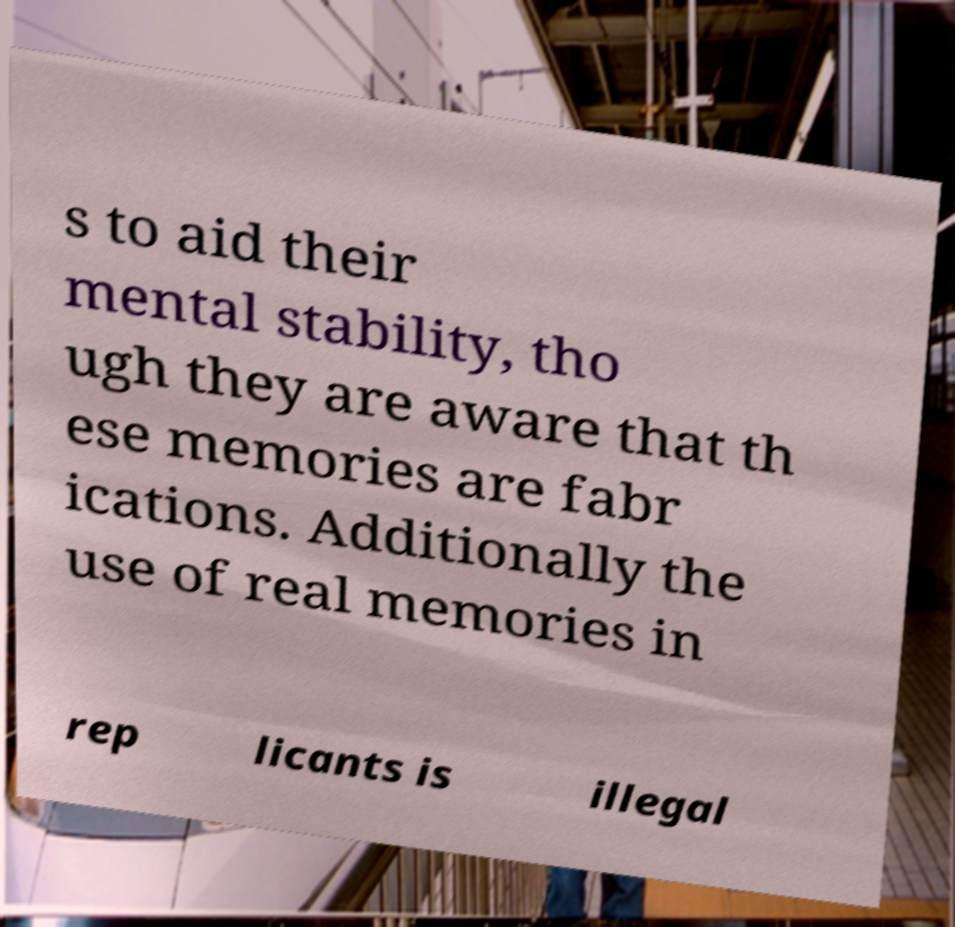Can you accurately transcribe the text from the provided image for me? s to aid their mental stability, tho ugh they are aware that th ese memories are fabr ications. Additionally the use of real memories in rep licants is illegal 